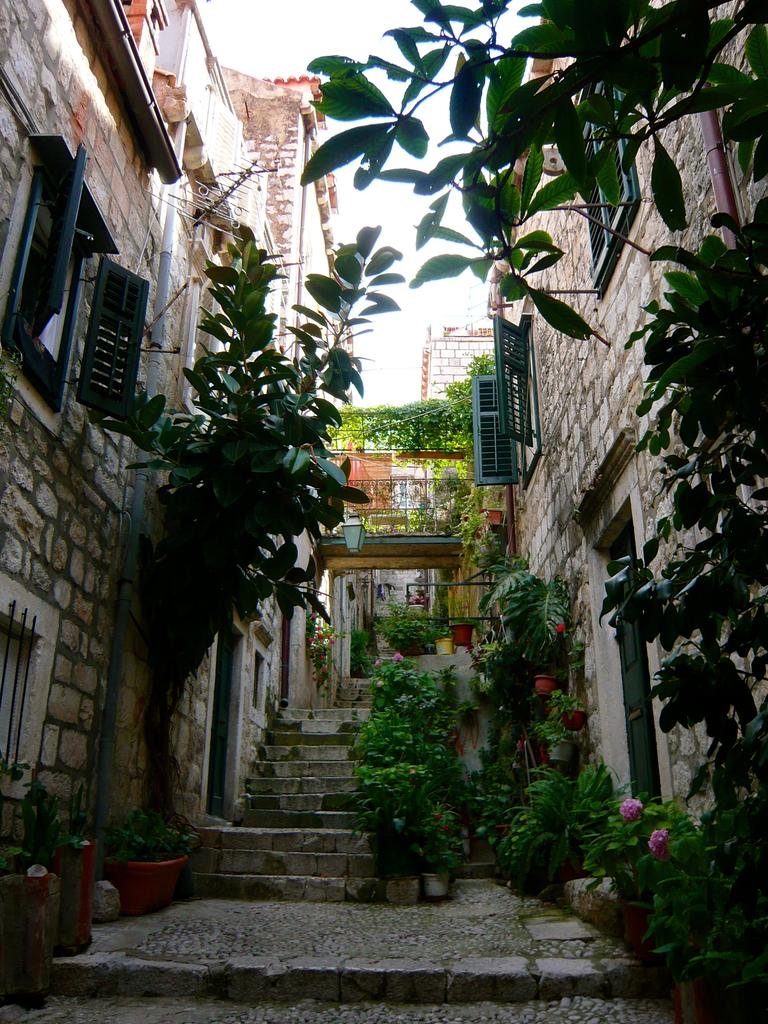What type of structures can be seen in the image? There are buildings in the image. What type of vegetation is present in the image? There are trees in the image. What type of plants are in pots in the image? There are potted plants in the image. What architectural feature can be seen in the image? There are staircases in the image. What type of chin is visible on the shirt of the person in the image? There is no person or shirt present in the image. What type of need is used to sew the shirt in the image? There is no shirt or sewing needles present in the image. 